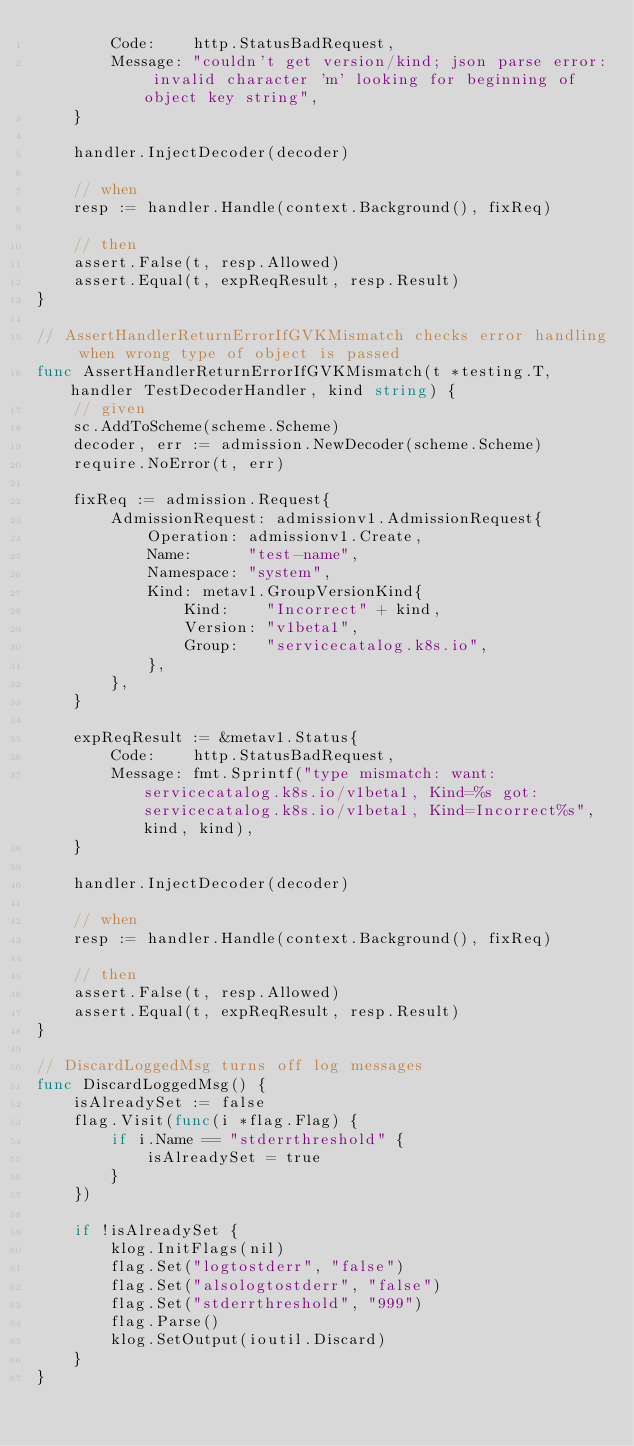<code> <loc_0><loc_0><loc_500><loc_500><_Go_>		Code:    http.StatusBadRequest,
		Message: "couldn't get version/kind; json parse error: invalid character 'm' looking for beginning of object key string",
	}

	handler.InjectDecoder(decoder)

	// when
	resp := handler.Handle(context.Background(), fixReq)

	// then
	assert.False(t, resp.Allowed)
	assert.Equal(t, expReqResult, resp.Result)
}

// AssertHandlerReturnErrorIfGVKMismatch checks error handling when wrong type of object is passed
func AssertHandlerReturnErrorIfGVKMismatch(t *testing.T, handler TestDecoderHandler, kind string) {
	// given
	sc.AddToScheme(scheme.Scheme)
	decoder, err := admission.NewDecoder(scheme.Scheme)
	require.NoError(t, err)

	fixReq := admission.Request{
		AdmissionRequest: admissionv1.AdmissionRequest{
			Operation: admissionv1.Create,
			Name:      "test-name",
			Namespace: "system",
			Kind: metav1.GroupVersionKind{
				Kind:    "Incorrect" + kind,
				Version: "v1beta1",
				Group:   "servicecatalog.k8s.io",
			},
		},
	}

	expReqResult := &metav1.Status{
		Code:    http.StatusBadRequest,
		Message: fmt.Sprintf("type mismatch: want: servicecatalog.k8s.io/v1beta1, Kind=%s got: servicecatalog.k8s.io/v1beta1, Kind=Incorrect%s", kind, kind),
	}

	handler.InjectDecoder(decoder)

	// when
	resp := handler.Handle(context.Background(), fixReq)

	// then
	assert.False(t, resp.Allowed)
	assert.Equal(t, expReqResult, resp.Result)
}

// DiscardLoggedMsg turns off log messages
func DiscardLoggedMsg() {
	isAlreadySet := false
	flag.Visit(func(i *flag.Flag) {
		if i.Name == "stderrthreshold" {
			isAlreadySet = true
		}
	})

	if !isAlreadySet {
		klog.InitFlags(nil)
		flag.Set("logtostderr", "false")
		flag.Set("alsologtostderr", "false")
		flag.Set("stderrthreshold", "999")
		flag.Parse()
		klog.SetOutput(ioutil.Discard)
	}
}
</code> 